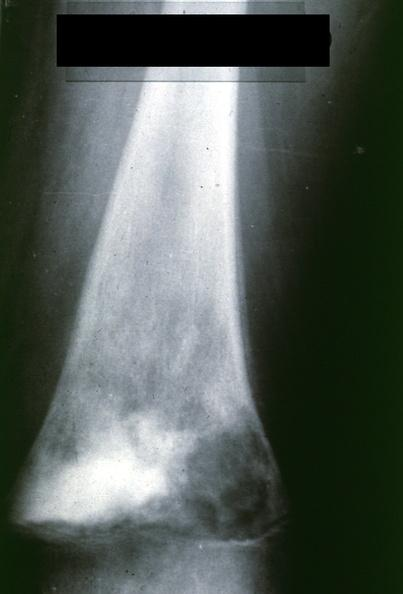what is?
Answer the question using a single word or phrase. Lateral view 